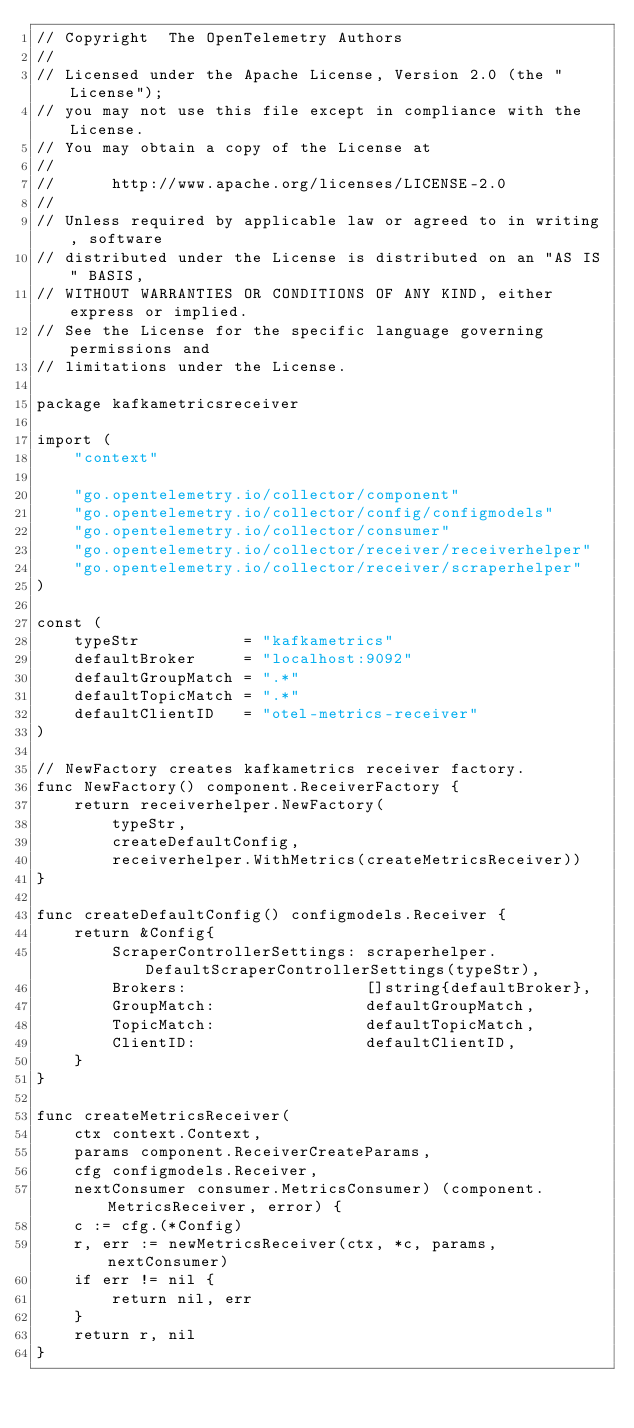<code> <loc_0><loc_0><loc_500><loc_500><_Go_>// Copyright  The OpenTelemetry Authors
//
// Licensed under the Apache License, Version 2.0 (the "License");
// you may not use this file except in compliance with the License.
// You may obtain a copy of the License at
//
//      http://www.apache.org/licenses/LICENSE-2.0
//
// Unless required by applicable law or agreed to in writing, software
// distributed under the License is distributed on an "AS IS" BASIS,
// WITHOUT WARRANTIES OR CONDITIONS OF ANY KIND, either express or implied.
// See the License for the specific language governing permissions and
// limitations under the License.

package kafkametricsreceiver

import (
	"context"

	"go.opentelemetry.io/collector/component"
	"go.opentelemetry.io/collector/config/configmodels"
	"go.opentelemetry.io/collector/consumer"
	"go.opentelemetry.io/collector/receiver/receiverhelper"
	"go.opentelemetry.io/collector/receiver/scraperhelper"
)

const (
	typeStr           = "kafkametrics"
	defaultBroker     = "localhost:9092"
	defaultGroupMatch = ".*"
	defaultTopicMatch = ".*"
	defaultClientID   = "otel-metrics-receiver"
)

// NewFactory creates kafkametrics receiver factory.
func NewFactory() component.ReceiverFactory {
	return receiverhelper.NewFactory(
		typeStr,
		createDefaultConfig,
		receiverhelper.WithMetrics(createMetricsReceiver))
}

func createDefaultConfig() configmodels.Receiver {
	return &Config{
		ScraperControllerSettings: scraperhelper.DefaultScraperControllerSettings(typeStr),
		Brokers:                   []string{defaultBroker},
		GroupMatch:                defaultGroupMatch,
		TopicMatch:                defaultTopicMatch,
		ClientID:                  defaultClientID,
	}
}

func createMetricsReceiver(
	ctx context.Context,
	params component.ReceiverCreateParams,
	cfg configmodels.Receiver,
	nextConsumer consumer.MetricsConsumer) (component.MetricsReceiver, error) {
	c := cfg.(*Config)
	r, err := newMetricsReceiver(ctx, *c, params, nextConsumer)
	if err != nil {
		return nil, err
	}
	return r, nil
}
</code> 